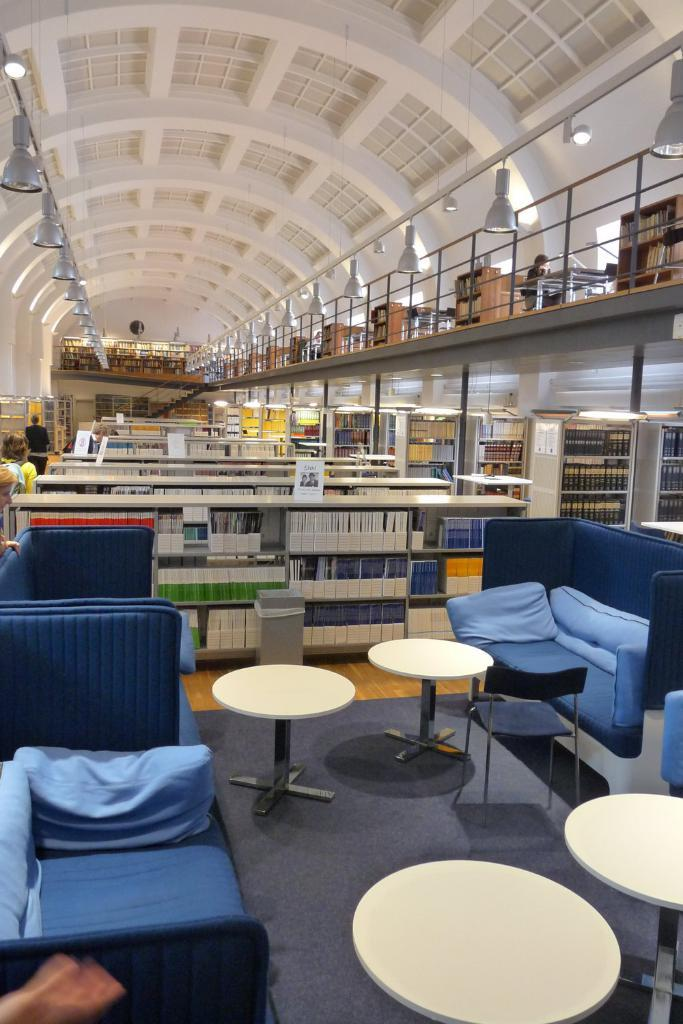What color are the sofas in the image? There are blue sofas on either side. What color are the tables in the image? There are white tables in the middle. What can be found between the sofas and tables? There are many bookshelves in front of the sofas and tables. How many buttons are on the blue sofa in the image? There are no buttons visible on the blue sofas in the image. What type of butter is being used to decorate the white tables in the image? There is no butter present in the image; the tables are white and have no visible decorations. 